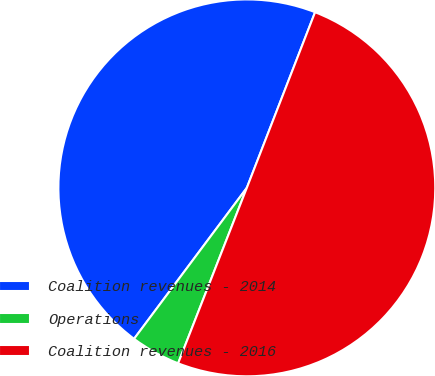Convert chart to OTSL. <chart><loc_0><loc_0><loc_500><loc_500><pie_chart><fcel>Coalition revenues - 2014<fcel>Operations<fcel>Coalition revenues - 2016<nl><fcel>45.69%<fcel>4.27%<fcel>50.04%<nl></chart> 